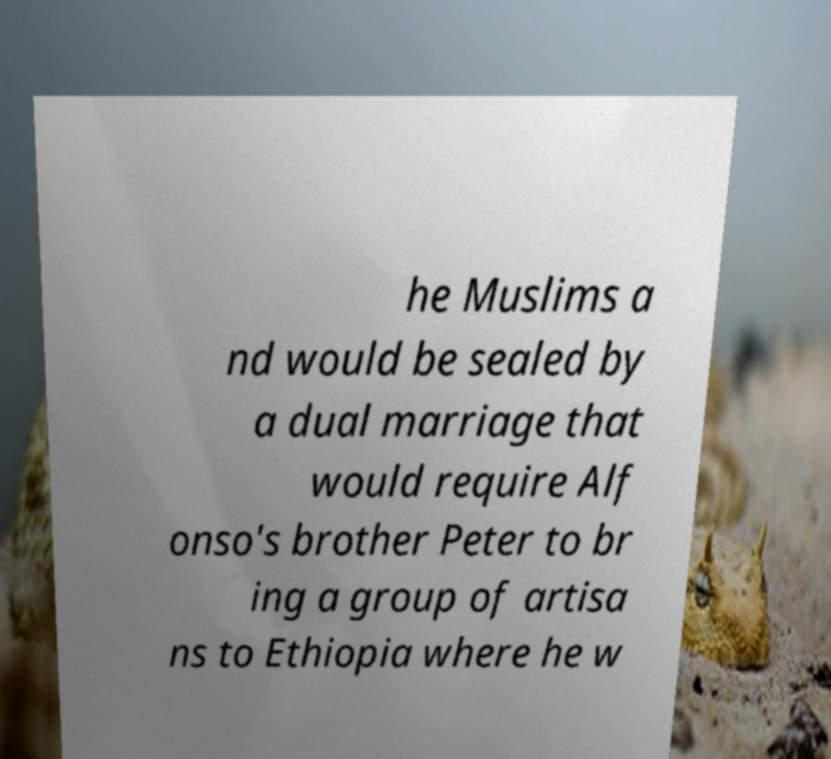There's text embedded in this image that I need extracted. Can you transcribe it verbatim? he Muslims a nd would be sealed by a dual marriage that would require Alf onso's brother Peter to br ing a group of artisa ns to Ethiopia where he w 